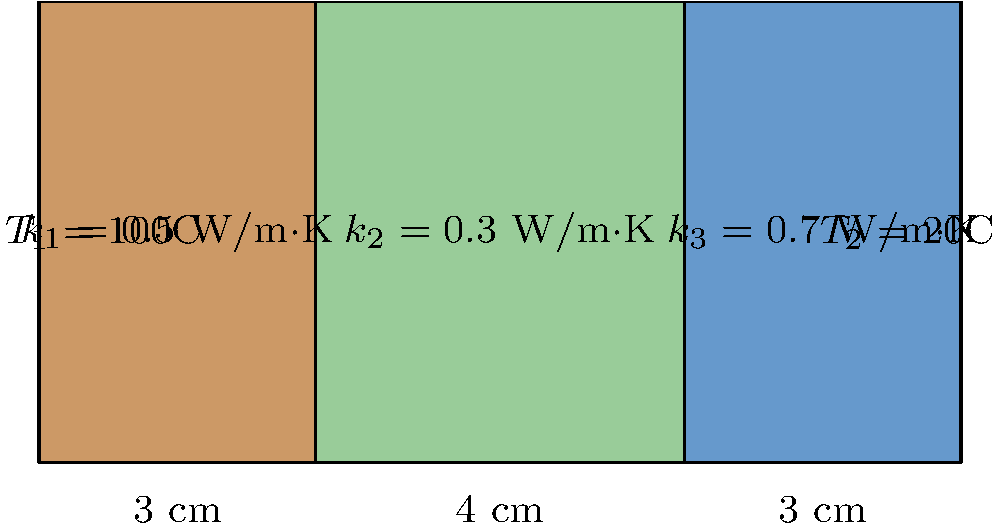As a software engineer working on a document management platform for engineering applications, you need to implement a heat transfer calculation module. Given the composite wall shown in the diagram with three layers of different materials and thicknesses, calculate the overall heat transfer rate per unit area (heat flux) through the wall. Assume steady-state conditions and one-dimensional heat flow. To solve this problem, we'll use the concept of thermal resistance in series for a composite wall. Here's the step-by-step solution:

1. Calculate the thermal resistance of each layer:
   $R_i = \frac{L_i}{k_i}$, where $L_i$ is the thickness and $k_i$ is the thermal conductivity.

   Layer 1: $R_1 = \frac{0.03}{0.5} = 0.06$ m²·K/W
   Layer 2: $R_2 = \frac{0.04}{0.3} = 0.1333$ m²·K/W
   Layer 3: $R_3 = \frac{0.03}{0.7} = 0.0429$ m²·K/W

2. Calculate the total thermal resistance:
   $R_total = R_1 + R_2 + R_3 = 0.06 + 0.1333 + 0.0429 = 0.2362$ m²·K/W

3. Calculate the temperature difference:
   $\Delta T = T_1 - T_2 = 100°C - 20°C = 80°C$

4. Calculate the heat flux using Fourier's Law:
   $q = \frac{\Delta T}{R_total} = \frac{80}{0.2362} = 338.7$ W/m²

The heat flux through the composite wall is approximately 338.7 W/m².
Answer: 338.7 W/m² 